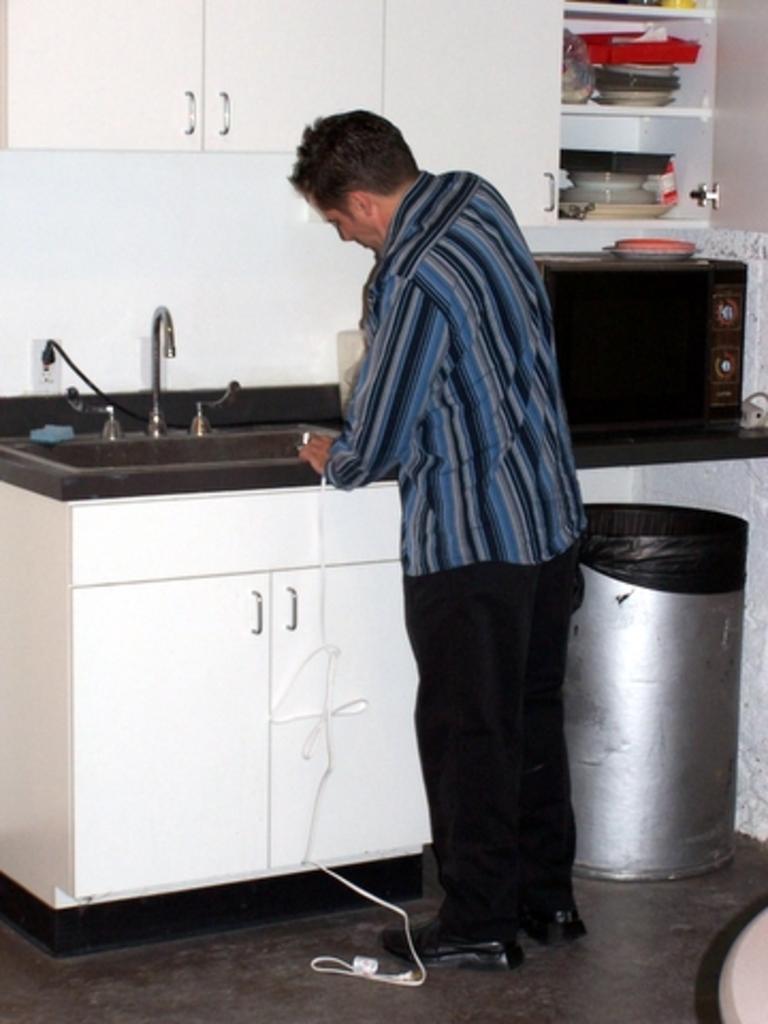Please provide a concise description of this image. This is an inside view. Here I can see a man standing in front of the table and holding an object in the hand. On the table I can see a tap is attached. Beside this man there is a dustbin which is placed on the floor. At the top there is a cupboard and a rack which is filled with the plates. 